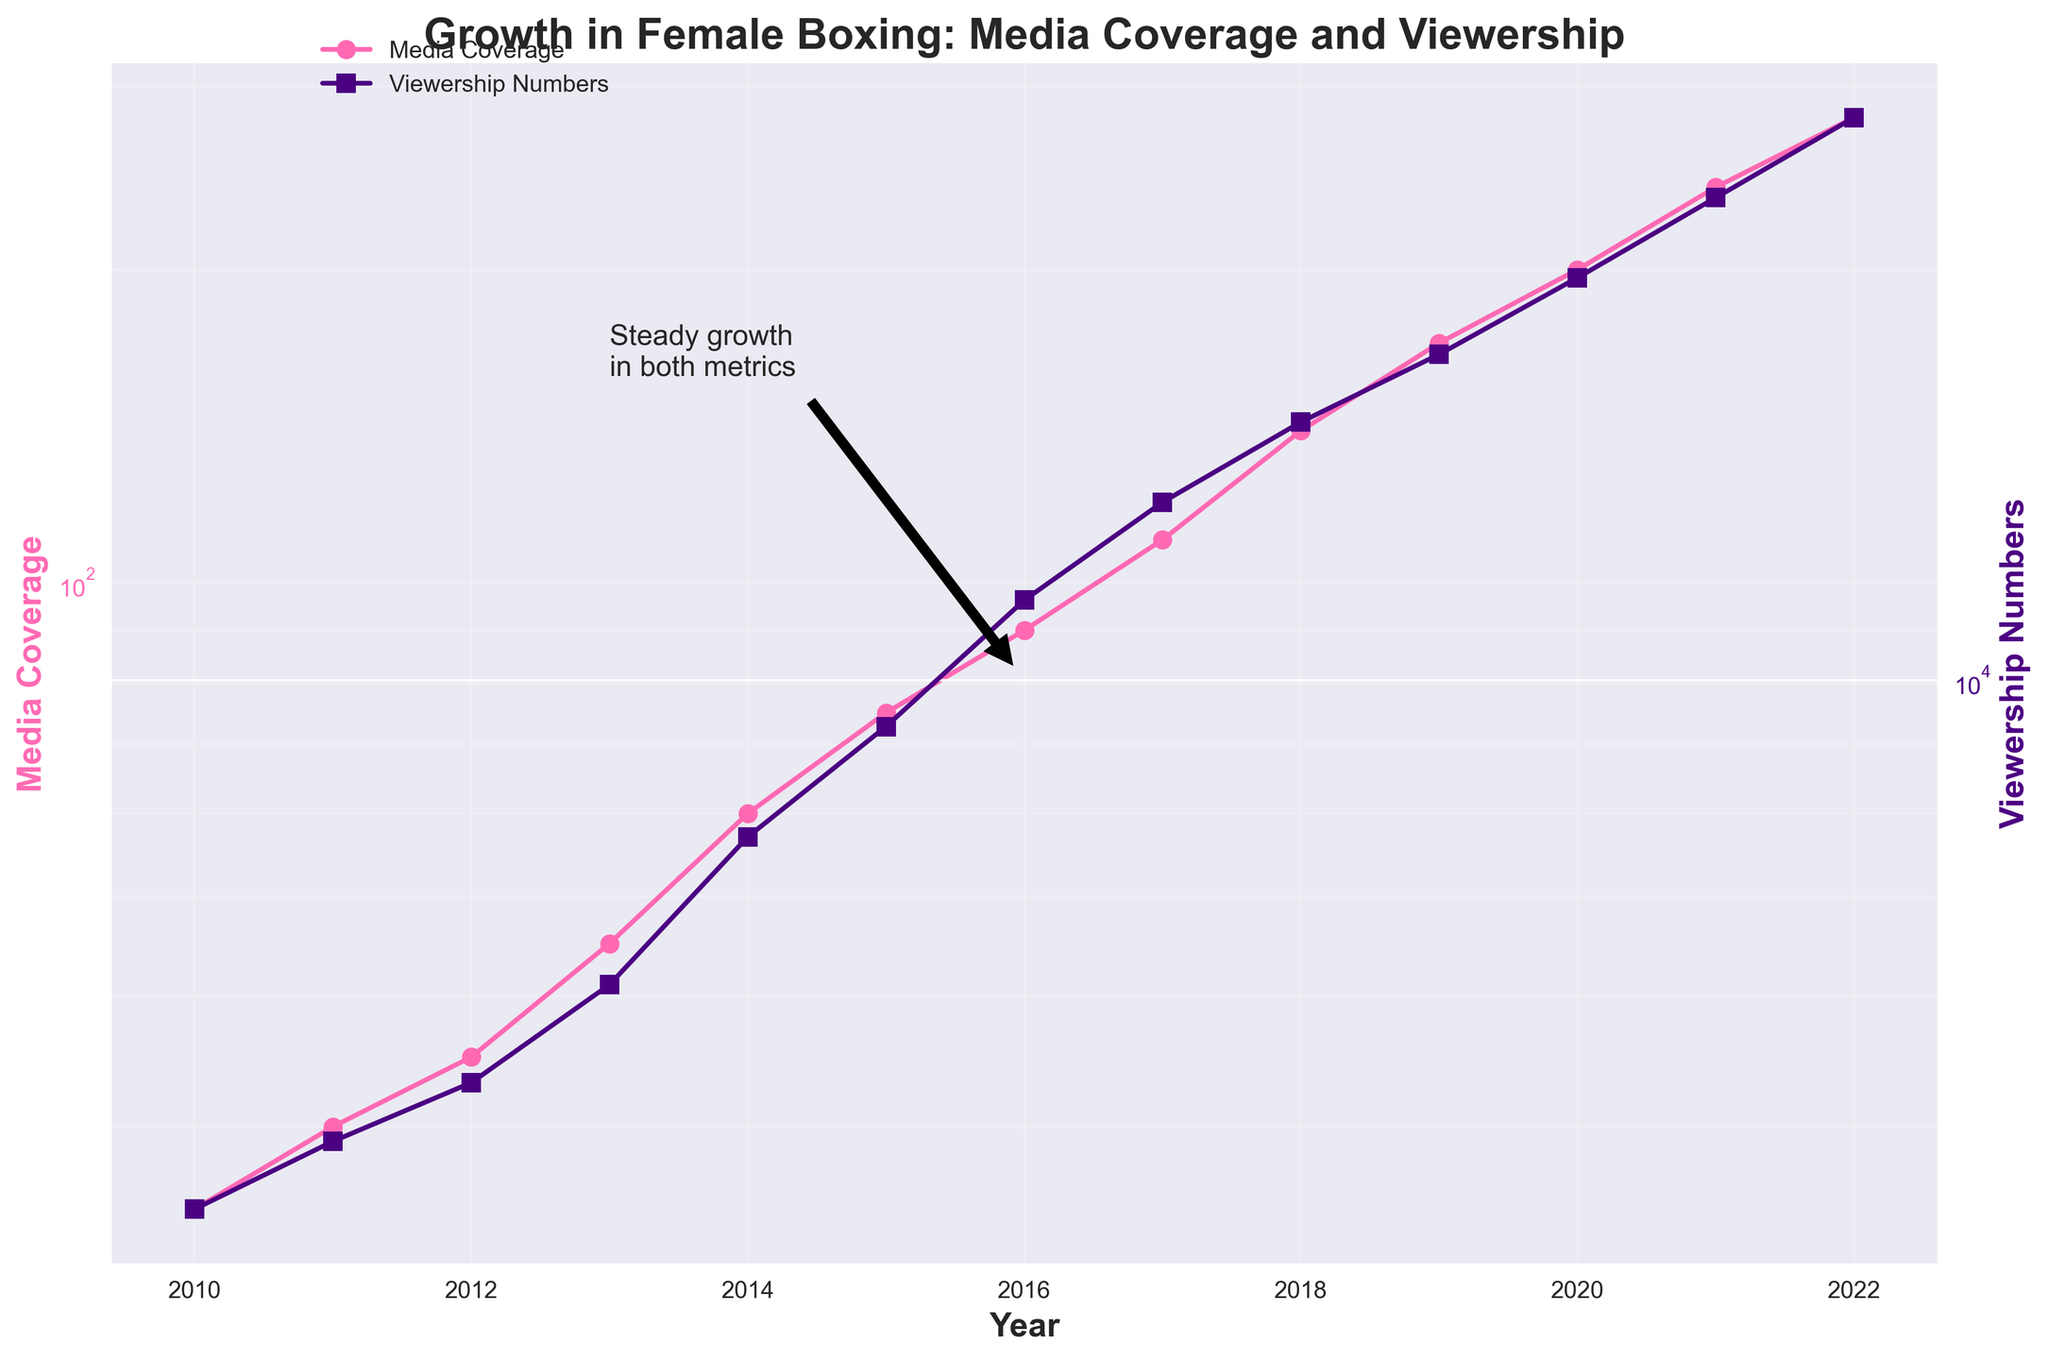What's the title of the figure? The title of the figure is usually located at the top and describes the content or purpose of the plot.
Answer: Growth in Female Boxing: Media Coverage and Viewership What are the two metrics displayed in the plot? The two metrics are typically labeled on the y-axes of the plot. The left y-axis is labeled "Media Coverage" and the right y-axis is labeled "Viewership Numbers".
Answer: Media Coverage, Viewership Numbers How many years of data are shown in the plot? The data spans from the first year to the last year shown on the x-axis.
Answer: 13 years In which year did Media Coverage first exceed 100? By following the Media Coverage line, you can locate the point where it first goes above 100 and identify the corresponding year on the x-axis.
Answer: 2017 What was the approximate viewership number in 2015? You can approximate the viewership by looking at the Viewership Numbers line and finding the y-value for the year 2015 on the x-axis.
Answer: 9000 What years show the greatest increase in Viewership Numbers? The greatest increase can be identified by observing the steepest part of the Viewership Numbers line between consecutive years. This is from 2020 to 2022.
Answer: 2020 to 2022 What is the ratio of Viewership Numbers to Media Coverage in 2022? To find this, take the viewership number in 2022 and divide it by the media coverage number in the same year. This is 36000 / 280.
Answer: 128.57 How do the trends of Media Coverage and Viewership Numbers compare over the years? Analyzing the general direction and relative steepness of both lines over time helps compare trends. Both lines show an increasing trend with similar relative growth patterns throughout the years.
Answer: Both are increasing with similar trends Which metric grows more rapidly based on the log scale? By observing the slopes of the two lines on the log scale, the one with the steeper slope would indicate more rapid growth.
Answer: Media Coverage What major trend can be observed in both metrics from 2010 to 2022? Look for the general direction and note any significant changes in both lines from 2010 to 2022. Both metrics show a steady increase, indicating growing interest and investment in female boxing.
Answer: Steady increase in both metrics 